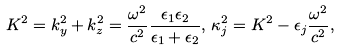Convert formula to latex. <formula><loc_0><loc_0><loc_500><loc_500>K ^ { 2 } = k _ { y } ^ { 2 } + k _ { z } ^ { 2 } = \frac { \omega ^ { 2 } } { c ^ { 2 } } \frac { \epsilon _ { 1 } \epsilon _ { 2 } } { \epsilon _ { 1 } + \epsilon _ { 2 } } , \, \kappa _ { j } ^ { 2 } = K ^ { 2 } - \epsilon _ { j } \frac { \omega ^ { 2 } } { c ^ { 2 } } ,</formula> 